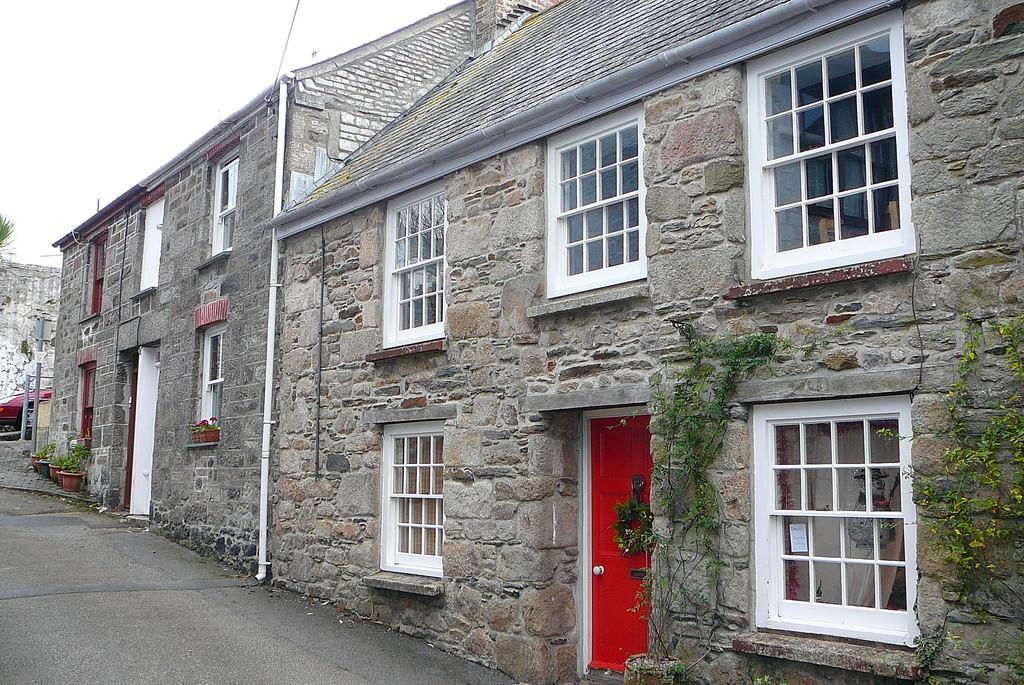What type of structures can be seen in the image? There are houses in the image. What natural element is present in the image? There is a tree in the image. What man-made object can be seen in the image? There is a vehicle in the image. What type of vegetation is visible in the image? There are plants in the image. What is visible in the background of the image? The sky is visible in the background of the image. Can you tell me how many ears of corn are growing on the tree in the image? There is no corn present in the image; it features a tree and other elements mentioned in the facts. What type of balls are being used to play a game in the image? There are no balls or games present in the image; it features houses, a tree, a vehicle, plants, and the sky. 